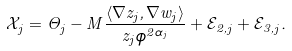<formula> <loc_0><loc_0><loc_500><loc_500>\mathcal { X } _ { j } = \Theta _ { j } - M \frac { \langle \nabla z _ { j } , \nabla w _ { j } \rangle } { z _ { j } \phi ^ { 2 \alpha _ { j } } } + \mathcal { E } _ { 2 , j } + \mathcal { E } _ { 3 , j } .</formula> 